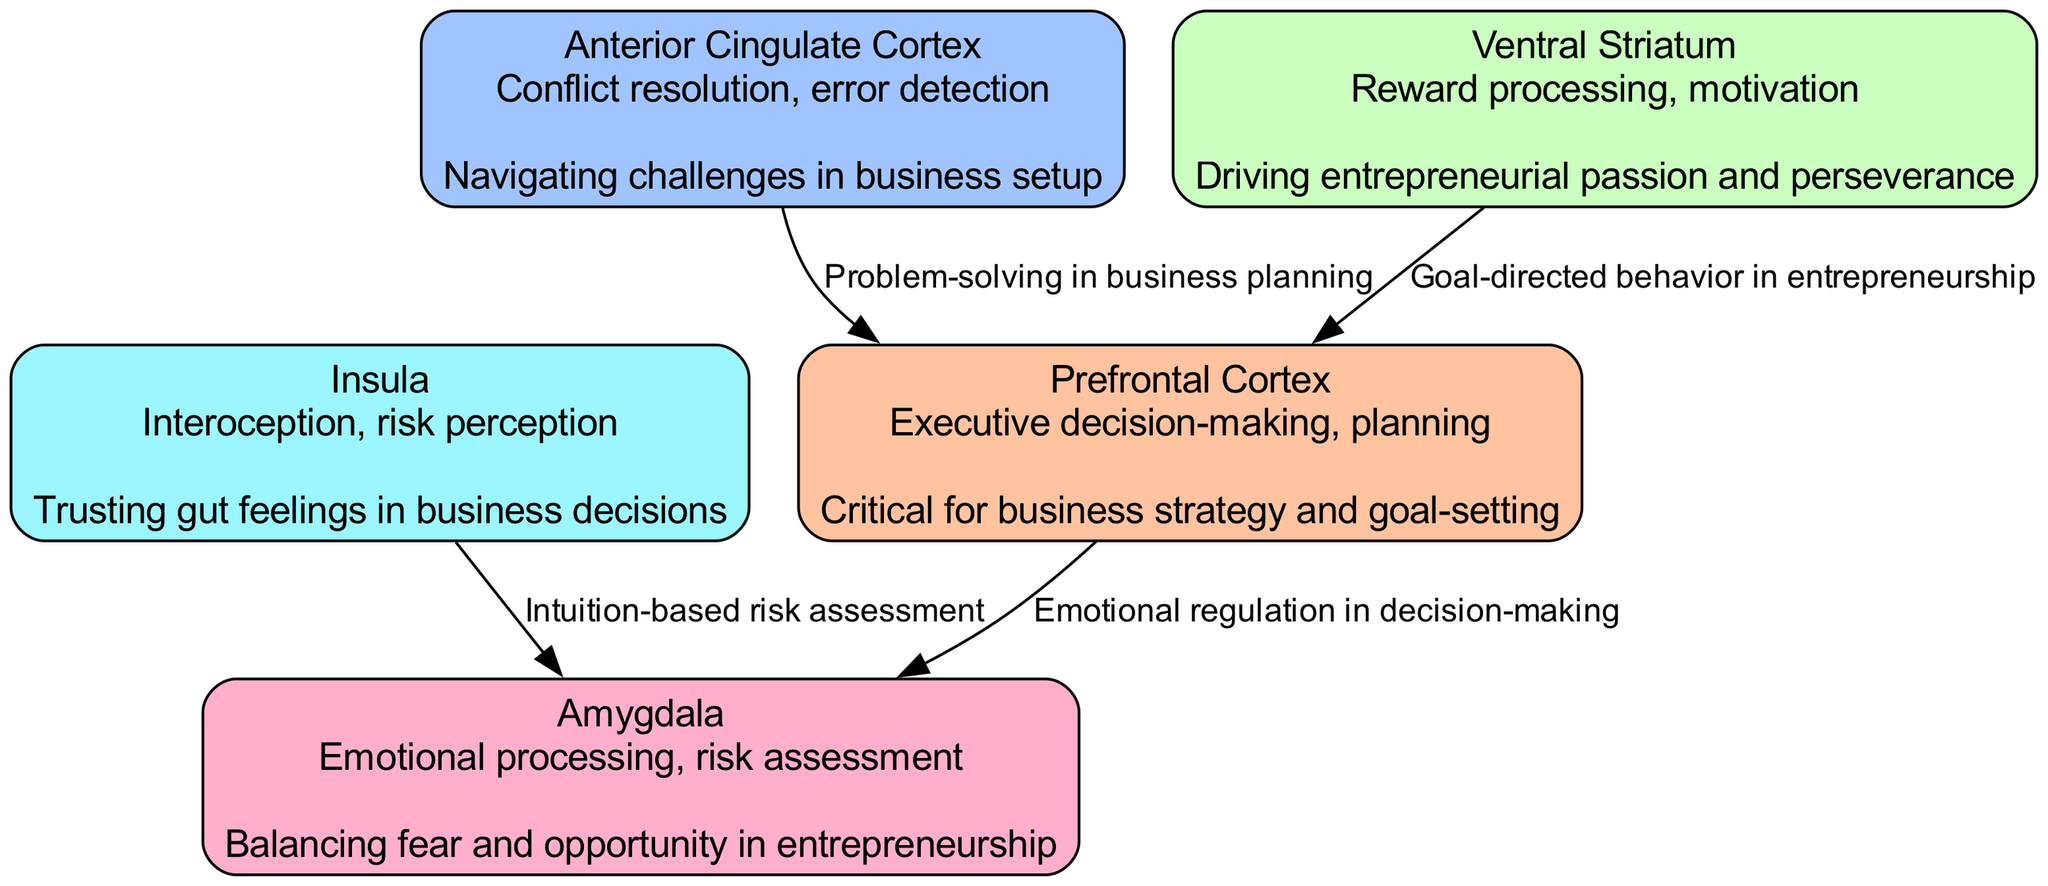What's the total number of brain regions identified in the diagram? The diagram lists five distinct brain regions involved in decision-making and risk assessment, which are the Prefrontal Cortex, Amygdala, Anterior Cingulate Cortex, Insula, and Ventral Striatum. Count the listed nodes to reach the total.
Answer: 5 Which brain region is primarily associated with conflict resolution? The Anterior Cingulate Cortex is specified in the diagram as responsible for conflict resolution. This is clarified through its function description provided within the node.
Answer: Anterior Cingulate Cortex How many connections are there between the brain regions? The diagram outlines four connections between regions. Each connection is represented as an edge linking two brain regions, so counting the listed connections reveals the total.
Answer: 4 What role does the Insula play in decision-making according to the diagram? The Insula is described as involved in interoception and risk perception, which means it plays a role in sensing internal states and assessing risks during decision-making. The node description provides this function clearly.
Answer: Interoception, risk perception Which brain region connects to the Prefrontal Cortex to indicate goal-directed behavior? The Ventral Striatum connects to the Prefrontal Cortex, highlighting its role in goal-directed behavior as indicated by the specific connection description in the diagram.
Answer: Ventral Striatum How does the Insula influence the Amygdala in decision-making processes? The Insula influences the Amygdala through the relationship "intuition-based risk assessment," as indicated by the connection in the diagram, thus showing how intuition plays a role in emotional processing during decisions.
Answer: Intuition-based risk assessment Which brain region is identified as critical for business strategy and goal-setting? The Prefrontal Cortex is noted as crucial for executive decision-making and planning, emphasizing its importance in business strategy and goal-setting, as indicated in the node description.
Answer: Prefrontal Cortex What role does the Amygdala serve in the context of entrepreneurship? The Amygdala is involved in emotional processing and risk assessment, helping to balance fear and opportunity which is essential in the entrepreneurial context, as described in the diagram.
Answer: Emotional processing, risk assessment What is the relationship between the Anterior Cingulate Cortex and the Prefrontal Cortex? The relationship is described as "problem-solving in business planning," which indicates that the Anterior Cingulate Cortex aids the Prefrontal Cortex in resolving issues during business planning processes.
Answer: Problem-solving in business planning 